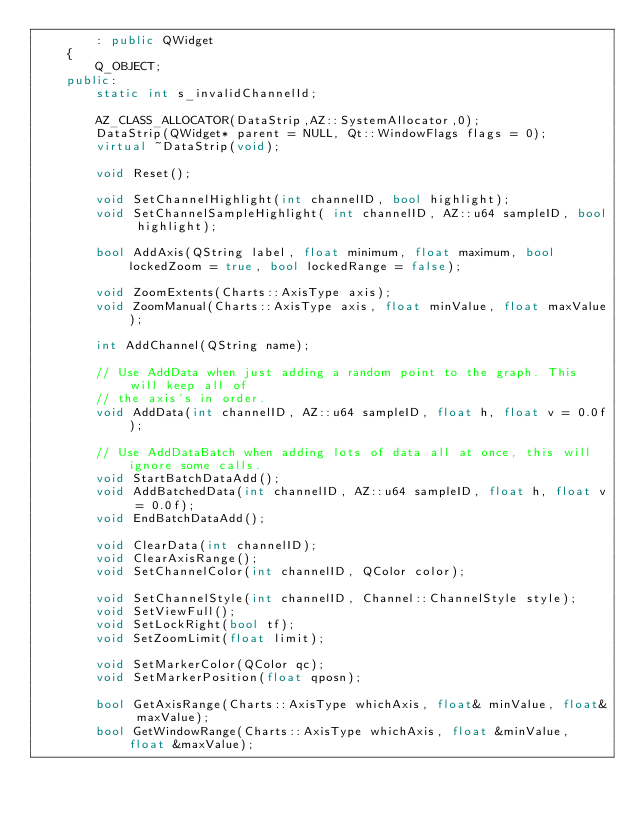<code> <loc_0><loc_0><loc_500><loc_500><_C++_>        : public QWidget
    {
        Q_OBJECT;
    public:
        static int s_invalidChannelId;

        AZ_CLASS_ALLOCATOR(DataStrip,AZ::SystemAllocator,0);
        DataStrip(QWidget* parent = NULL, Qt::WindowFlags flags = 0);
        virtual ~DataStrip(void);

        void Reset();

        void SetChannelHighlight(int channelID, bool highlight);
        void SetChannelSampleHighlight( int channelID, AZ::u64 sampleID, bool highlight);

        bool AddAxis(QString label, float minimum, float maximum, bool lockedZoom = true, bool lockedRange = false);

        void ZoomExtents(Charts::AxisType axis);
        void ZoomManual(Charts::AxisType axis, float minValue, float maxValue);

        int AddChannel(QString name);

        // Use AddData when just adding a random point to the graph. This will keep all of
        // the axis's in order.
        void AddData(int channelID, AZ::u64 sampleID, float h, float v = 0.0f);

        // Use AddDataBatch when adding lots of data all at once, this will ignore some calls.
        void StartBatchDataAdd();
        void AddBatchedData(int channelID, AZ::u64 sampleID, float h, float v = 0.0f);
        void EndBatchDataAdd();

        void ClearData(int channelID);
        void ClearAxisRange();
        void SetChannelColor(int channelID, QColor color);
        
        void SetChannelStyle(int channelID, Channel::ChannelStyle style);
        void SetViewFull();
        void SetLockRight(bool tf);
        void SetZoomLimit(float limit);

        void SetMarkerColor(QColor qc);
        void SetMarkerPosition(float qposn);

        bool GetAxisRange(Charts::AxisType whichAxis, float& minValue, float& maxValue);
        bool GetWindowRange(Charts::AxisType whichAxis, float &minValue, float &maxValue);</code> 